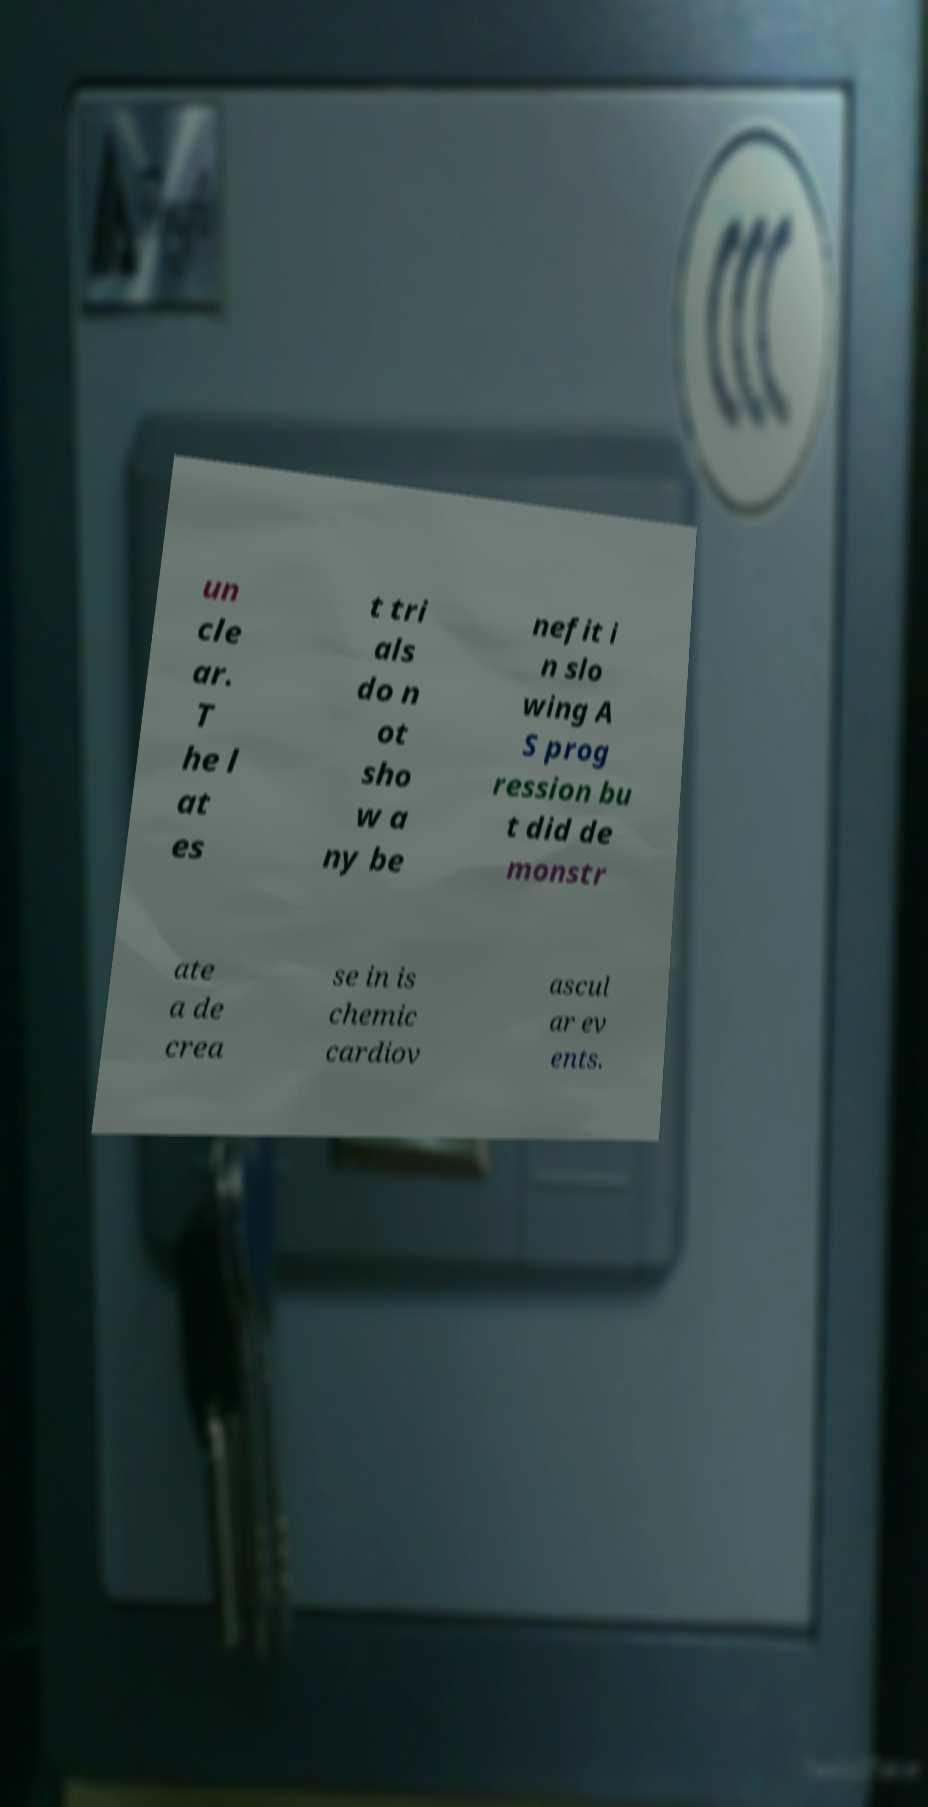What messages or text are displayed in this image? I need them in a readable, typed format. un cle ar. T he l at es t tri als do n ot sho w a ny be nefit i n slo wing A S prog ression bu t did de monstr ate a de crea se in is chemic cardiov ascul ar ev ents. 